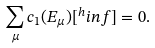<formula> <loc_0><loc_0><loc_500><loc_500>\sum _ { \mu } c _ { 1 } ( E _ { \mu } ) [ ^ { h } i n f ] = 0 .</formula> 